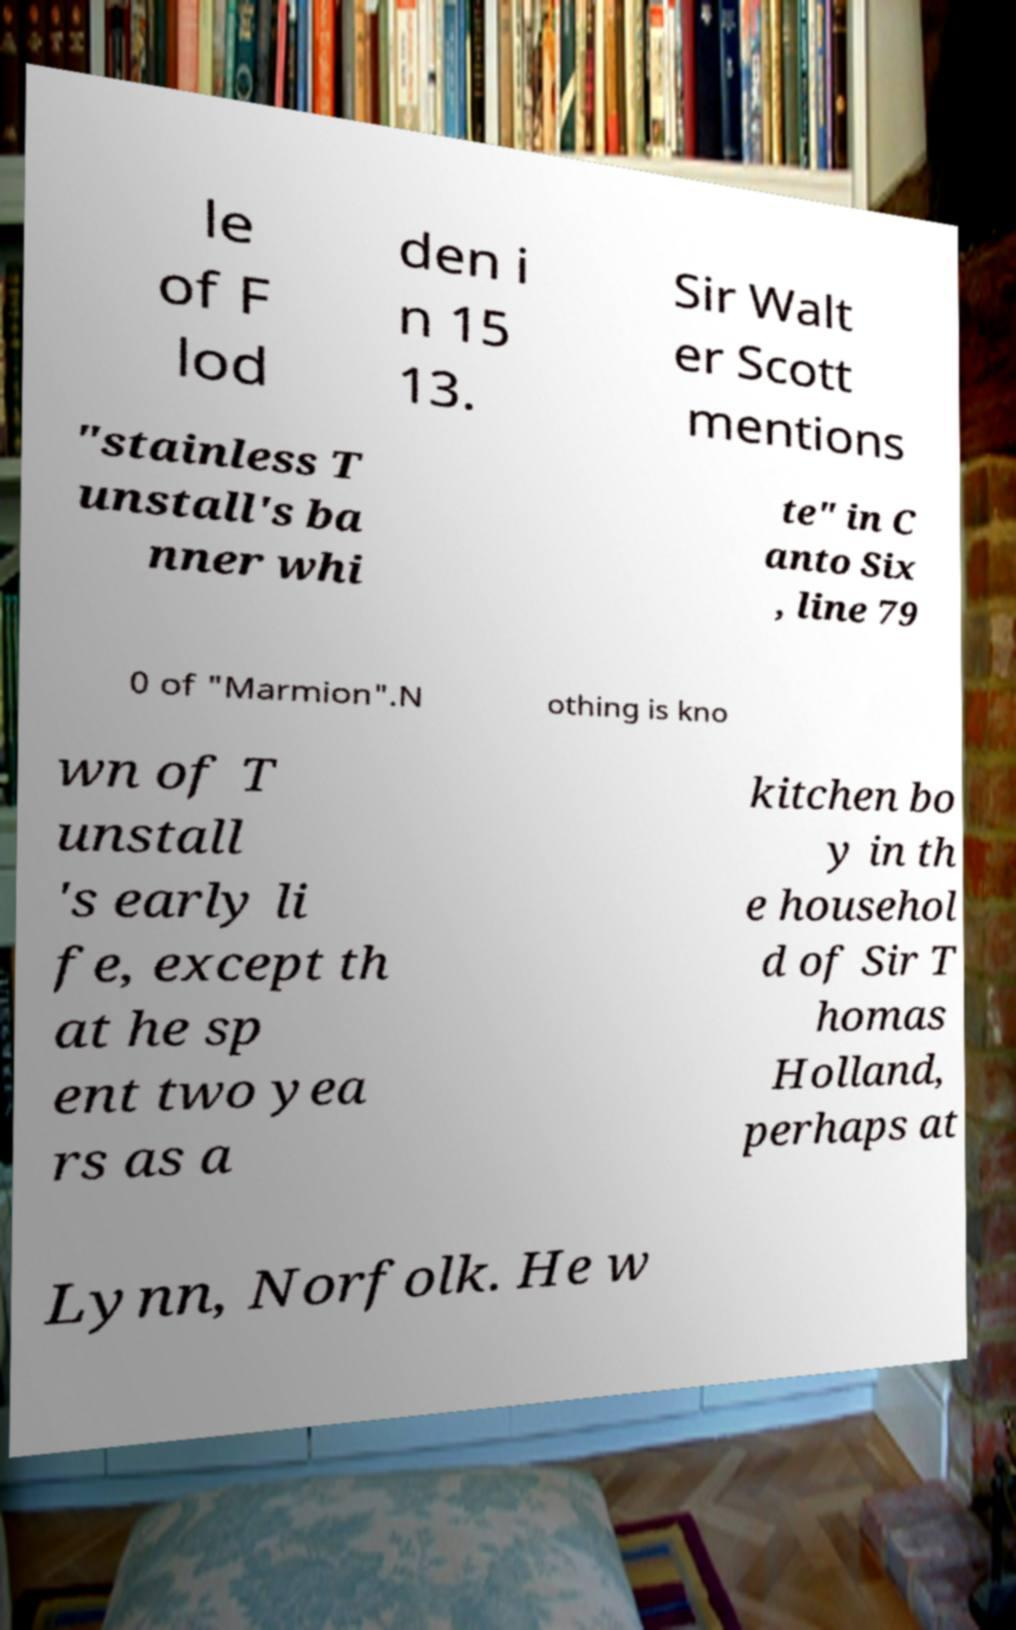There's text embedded in this image that I need extracted. Can you transcribe it verbatim? le of F lod den i n 15 13. Sir Walt er Scott mentions "stainless T unstall's ba nner whi te" in C anto Six , line 79 0 of "Marmion".N othing is kno wn of T unstall 's early li fe, except th at he sp ent two yea rs as a kitchen bo y in th e househol d of Sir T homas Holland, perhaps at Lynn, Norfolk. He w 